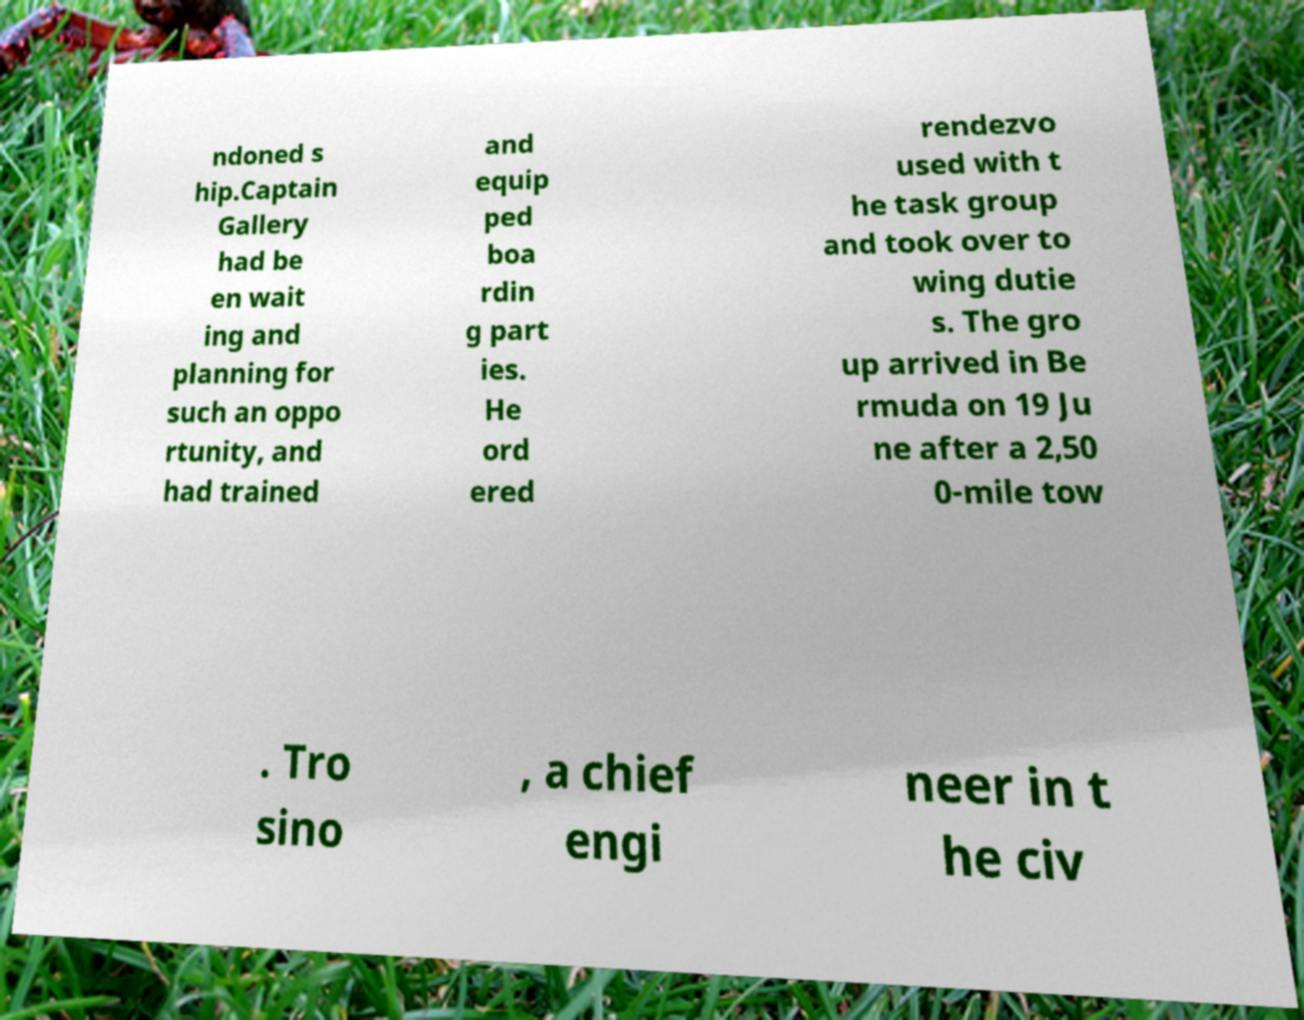Please read and relay the text visible in this image. What does it say? ndoned s hip.Captain Gallery had be en wait ing and planning for such an oppo rtunity, and had trained and equip ped boa rdin g part ies. He ord ered rendezvo used with t he task group and took over to wing dutie s. The gro up arrived in Be rmuda on 19 Ju ne after a 2,50 0-mile tow . Tro sino , a chief engi neer in t he civ 